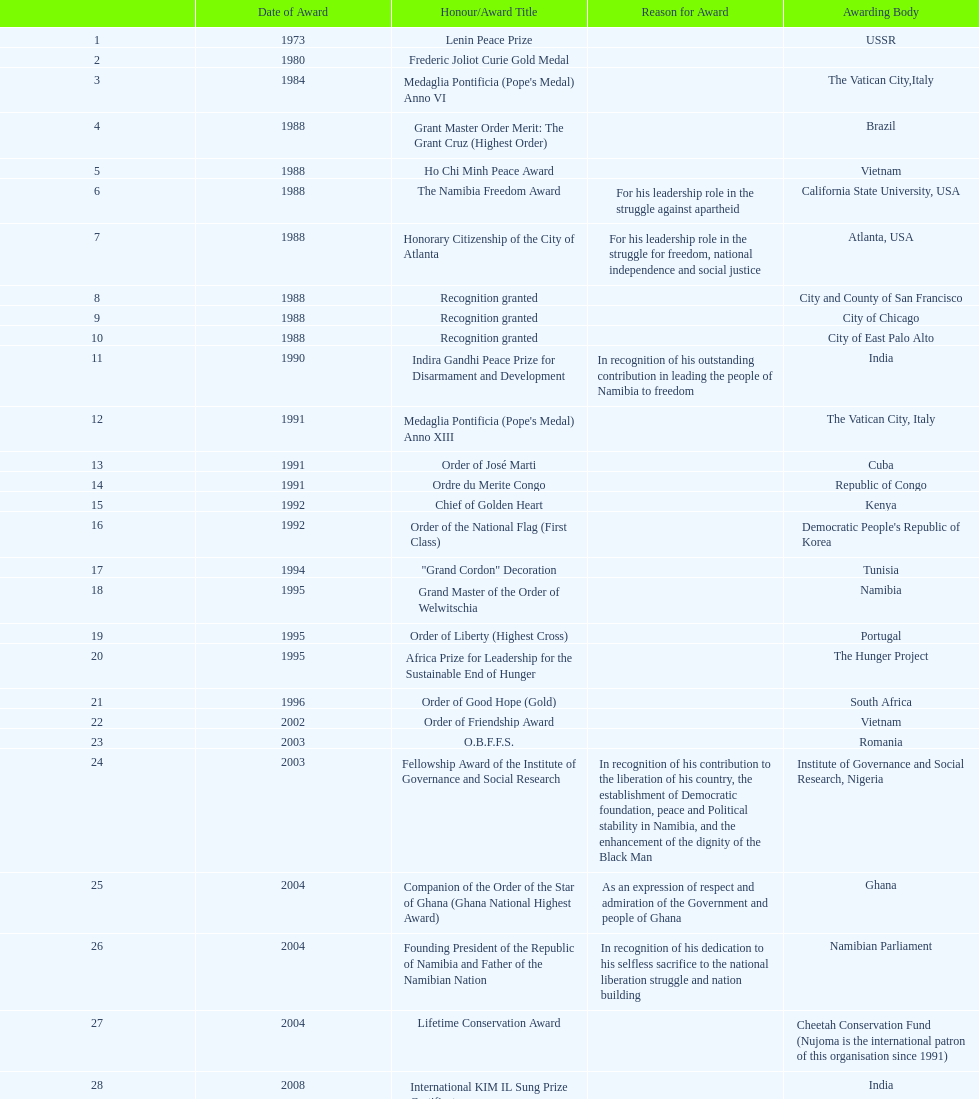On this chart, which title represents the most recent honors/award? Sir Seretse Khama SADC Meda. 